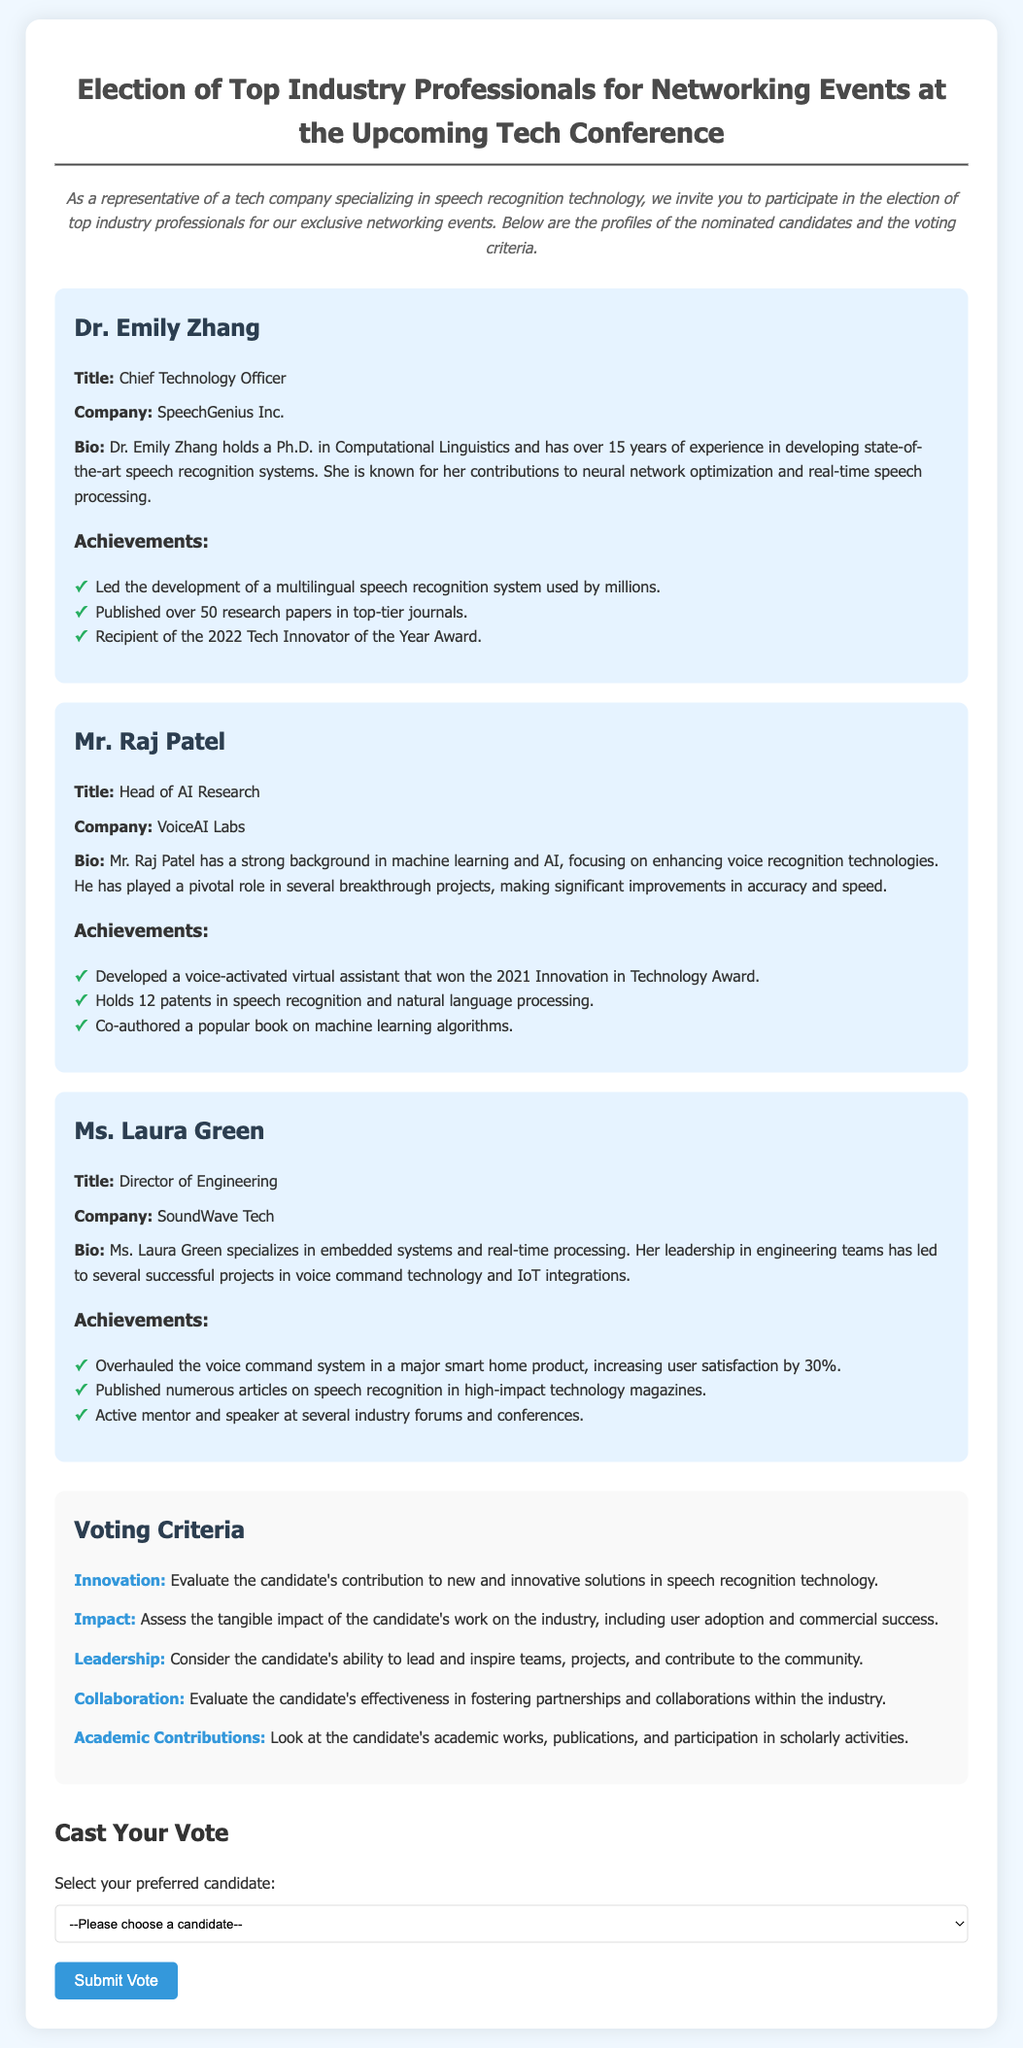What is Dr. Emily Zhang's title? Dr. Emily Zhang's title is mentioned in her profile as Chief Technology Officer.
Answer: Chief Technology Officer How many research papers has Dr. Emily Zhang published? The document states that Dr. Emily Zhang has published over 50 research papers in top-tier journals.
Answer: Over 50 What award did Mr. Raj Patel win in 2021? The document highlights that Mr. Raj Patel developed a voice-activated virtual assistant that won the 2021 Innovation in Technology Award.
Answer: Innovation in Technology Award What is one of Ms. Laura Green's areas of specialization? Ms. Laura Green's profile mentions that she specializes in embedded systems and real-time processing.
Answer: Embedded systems Which candidate is known for contributions to neural network optimization? According to the document, Dr. Emily Zhang is known for her contributions to neural network optimization.
Answer: Dr. Emily Zhang What aspect of voting criteria includes the candidate's academic works? The voting criteria involve "Academic Contributions" that pertain to the candidate's academic works and publications.
Answer: Academic Contributions How many patents does Mr. Raj Patel hold? The document notes that Mr. Raj Patel holds 12 patents in speech recognition and natural language processing.
Answer: 12 What is the purpose of the ballot? The ballot aims to elect top industry professionals for networking events at the upcoming tech conference.
Answer: Elect top industry professionals What candidate has experience in voice command technology? Ms. Laura Green has experience in voice command technology, as mentioned in her bio.
Answer: Ms. Laura Green 